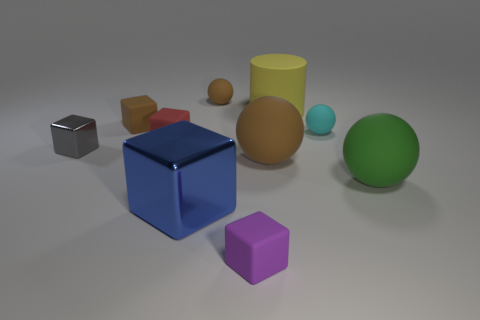Which objects are closest to the blue cube? The purple cube and the green sphere are the closest objects to the blue cube. 